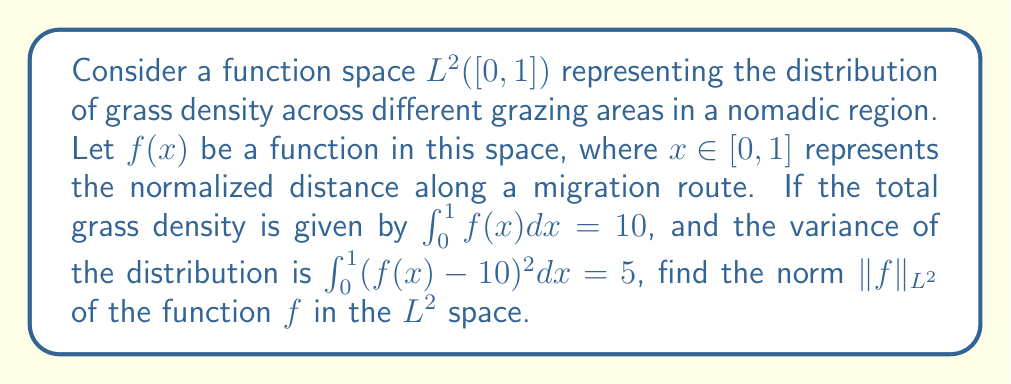Teach me how to tackle this problem. Let's approach this step-by-step:

1) In $L^2([0,1])$, the norm of a function $f$ is defined as:

   $$\|f\|_{L^2} = \sqrt{\int_0^1 |f(x)|^2 dx}$$

2) We're given two pieces of information:
   
   a) $\int_0^1 f(x) dx = 10$ (total grass density)
   
   b) $\int_0^1 (f(x) - 10)^2 dx = 5$ (variance)

3) Let's expand the variance equation:

   $$\int_0^1 (f(x) - 10)^2 dx = \int_0^1 (f(x)^2 - 20f(x) + 100) dx = 5$$

4) This can be rewritten as:

   $$\int_0^1 f(x)^2 dx - 20\int_0^1 f(x) dx + 100\int_0^1 dx = 5$$

5) We know $\int_0^1 f(x) dx = 10$ and $\int_0^1 dx = 1$, so:

   $$\int_0^1 f(x)^2 dx - 20(10) + 100 = 5$$

6) Simplifying:

   $$\int_0^1 f(x)^2 dx = 5 + 200 - 100 = 105$$

7) The left side of this equation is exactly what we need for the $L^2$ norm:

   $$\|f\|_{L^2} = \sqrt{\int_0^1 |f(x)|^2 dx} = \sqrt{105}$$
Answer: $\|f\|_{L^2} = \sqrt{105}$ 